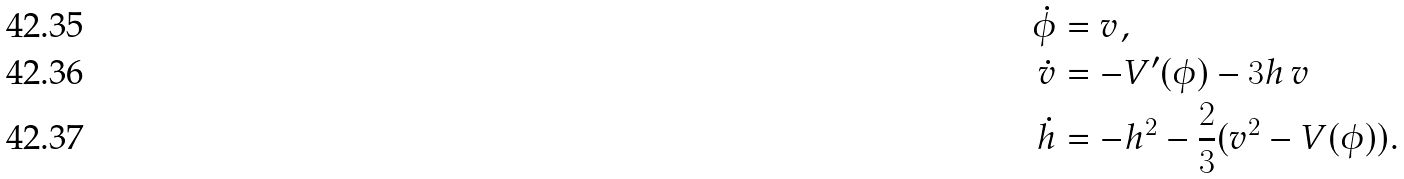Convert formula to latex. <formula><loc_0><loc_0><loc_500><loc_500>\dot { \phi } & = v , \\ \dot { v } & = - V ^ { \prime } ( \phi ) - 3 h \, v \, \\ \dot { h } & = - h ^ { 2 } - \frac { 2 } { 3 } ( v ^ { 2 } - V ( \phi ) ) .</formula> 